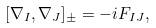<formula> <loc_0><loc_0><loc_500><loc_500>[ \nabla _ { I } , \nabla _ { J } ] _ { \pm } = - i F _ { I J } ,</formula> 